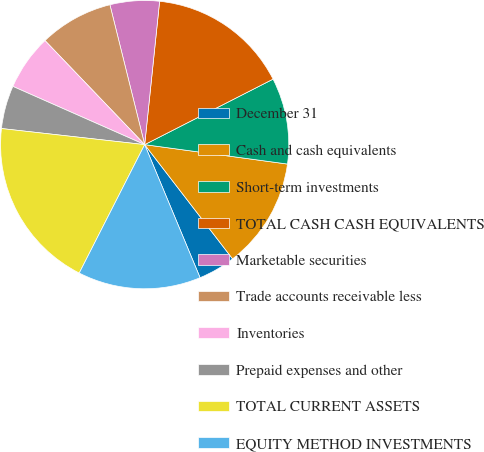Convert chart to OTSL. <chart><loc_0><loc_0><loc_500><loc_500><pie_chart><fcel>December 31<fcel>Cash and cash equivalents<fcel>Short-term investments<fcel>TOTAL CASH CASH EQUIVALENTS<fcel>Marketable securities<fcel>Trade accounts receivable less<fcel>Inventories<fcel>Prepaid expenses and other<fcel>TOTAL CURRENT ASSETS<fcel>EQUITY METHOD INVESTMENTS<nl><fcel>4.16%<fcel>12.41%<fcel>9.66%<fcel>15.84%<fcel>5.53%<fcel>8.28%<fcel>6.22%<fcel>4.84%<fcel>19.28%<fcel>13.78%<nl></chart> 